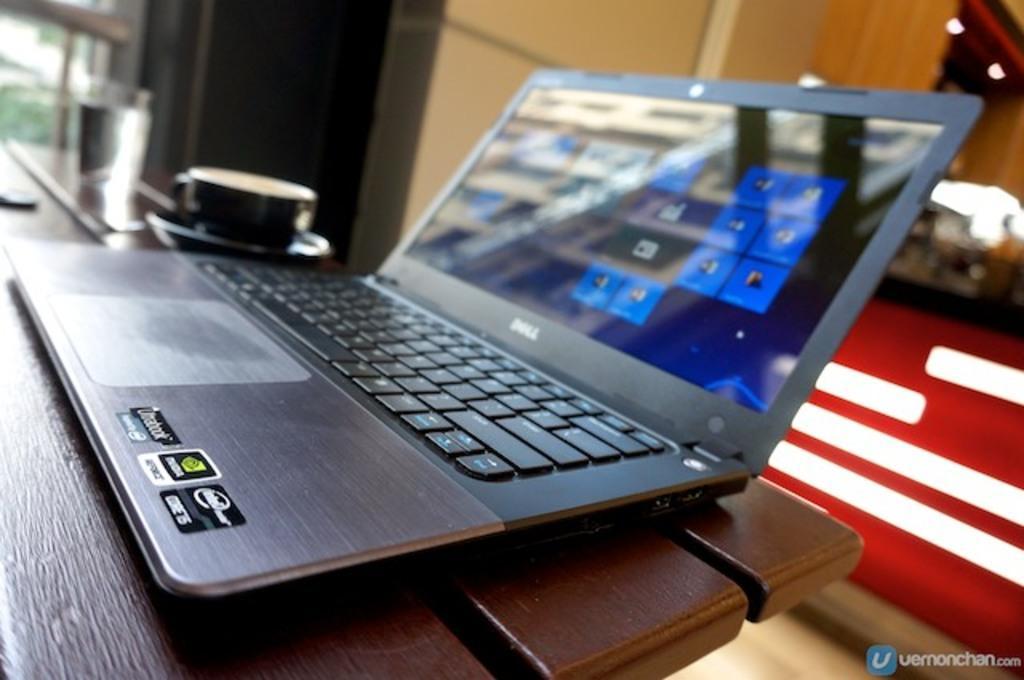In one or two sentences, can you explain what this image depicts? In the foreground I can see a table, laptop, tea cup and a text. In the background I can see a wall, trees and lights. This image is taken may be during a day. 